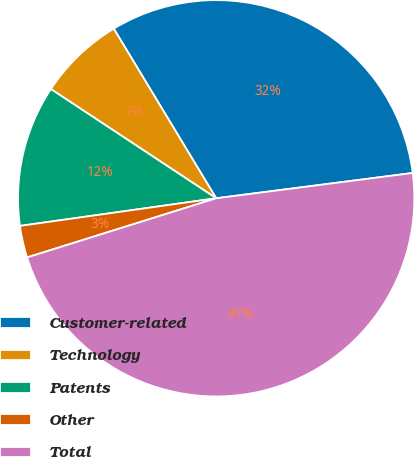Convert chart. <chart><loc_0><loc_0><loc_500><loc_500><pie_chart><fcel>Customer-related<fcel>Technology<fcel>Patents<fcel>Other<fcel>Total<nl><fcel>31.61%<fcel>7.06%<fcel>11.52%<fcel>2.6%<fcel>47.21%<nl></chart> 